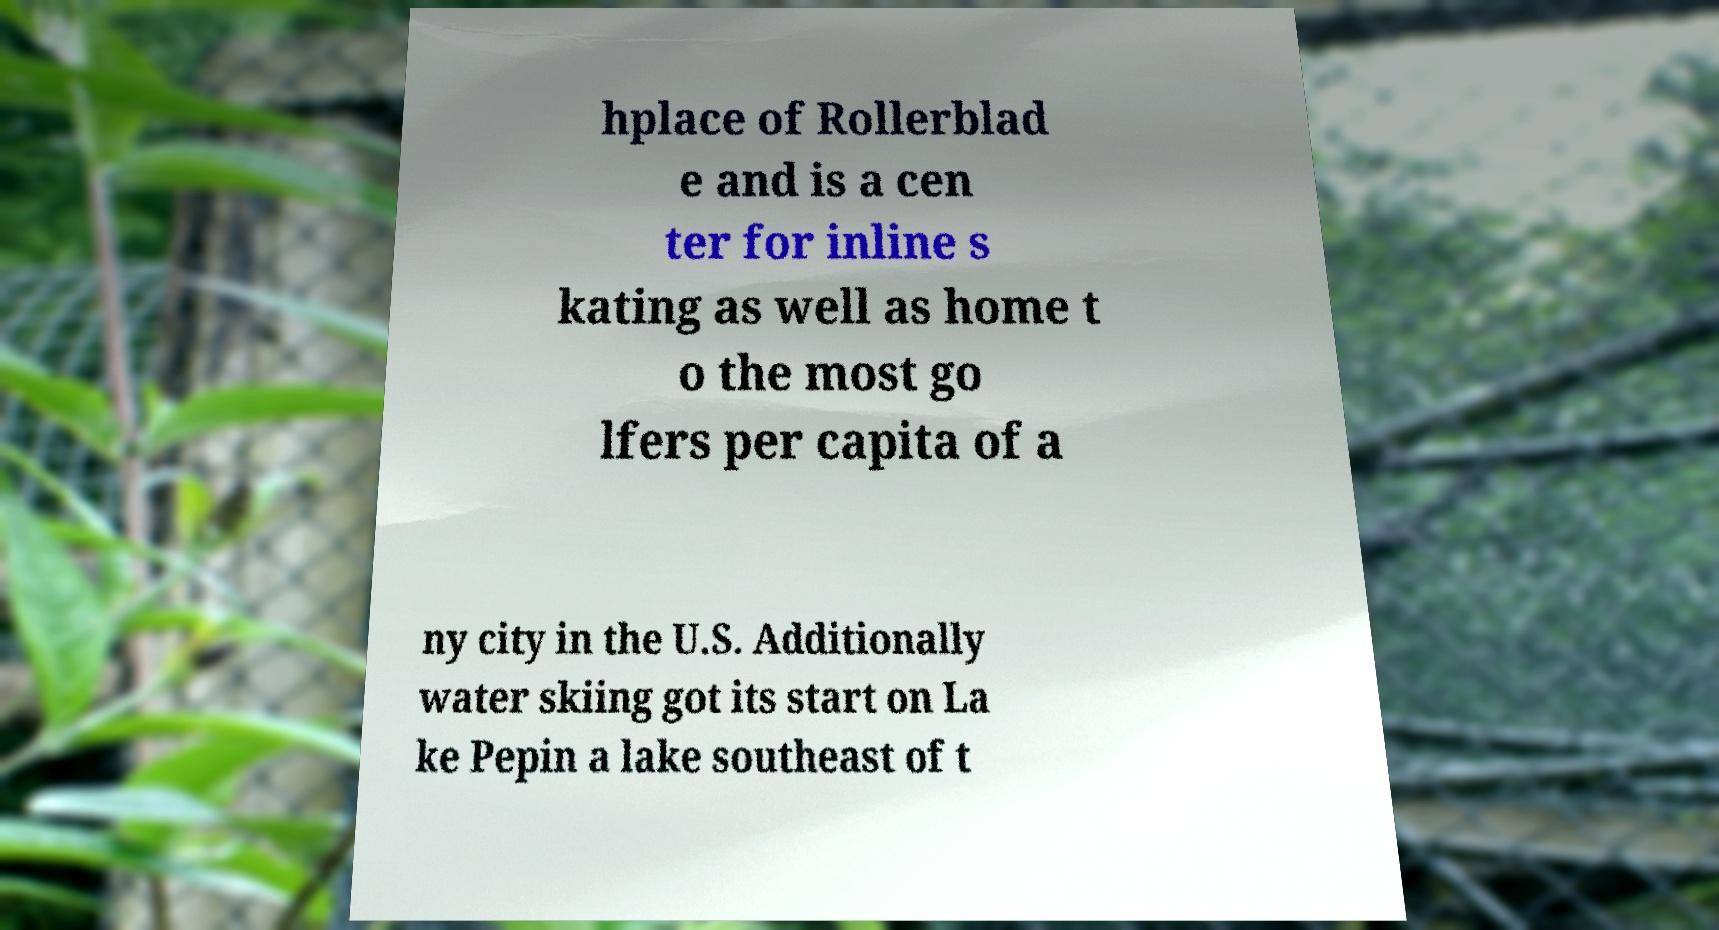Could you extract and type out the text from this image? hplace of Rollerblad e and is a cen ter for inline s kating as well as home t o the most go lfers per capita of a ny city in the U.S. Additionally water skiing got its start on La ke Pepin a lake southeast of t 